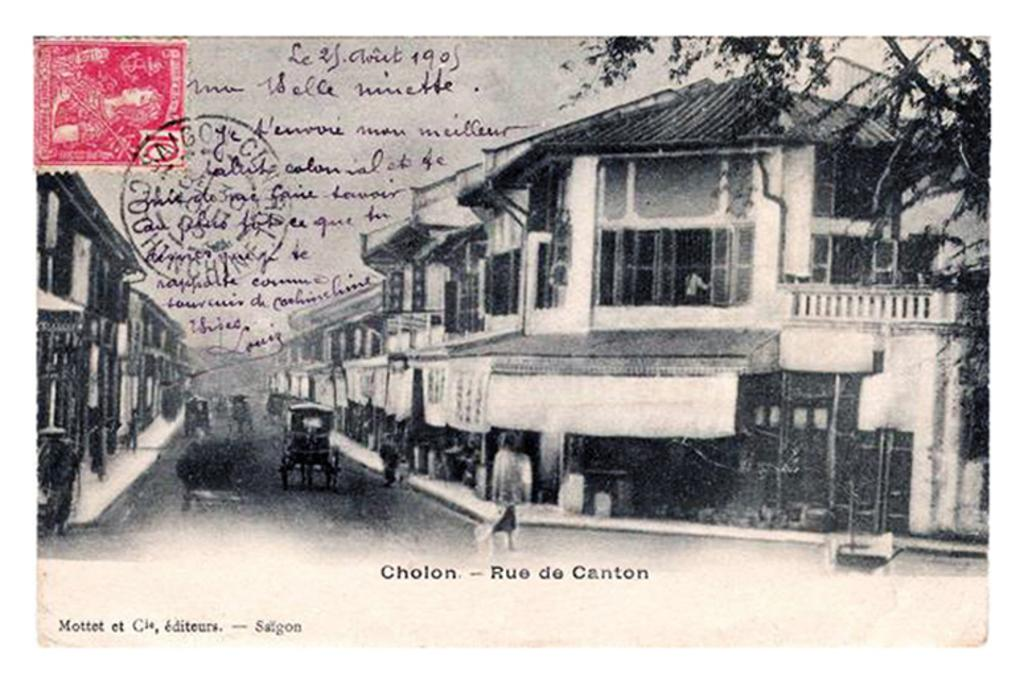What is the main subject of the image? There is a horse cart in the image. Where is the horse cart located? The horse cart is between buildings. What can be seen in the top left corner of the image? There is a stamp and written text in the top left corner of the image. What is present in the top right corner of the image? There is a branch in the top right corner of the image. What color is the gold crayon used to draw the clocks in the image? There is no gold crayon or clocks present in the image. 